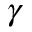Convert formula to latex. <formula><loc_0><loc_0><loc_500><loc_500>\gamma</formula> 